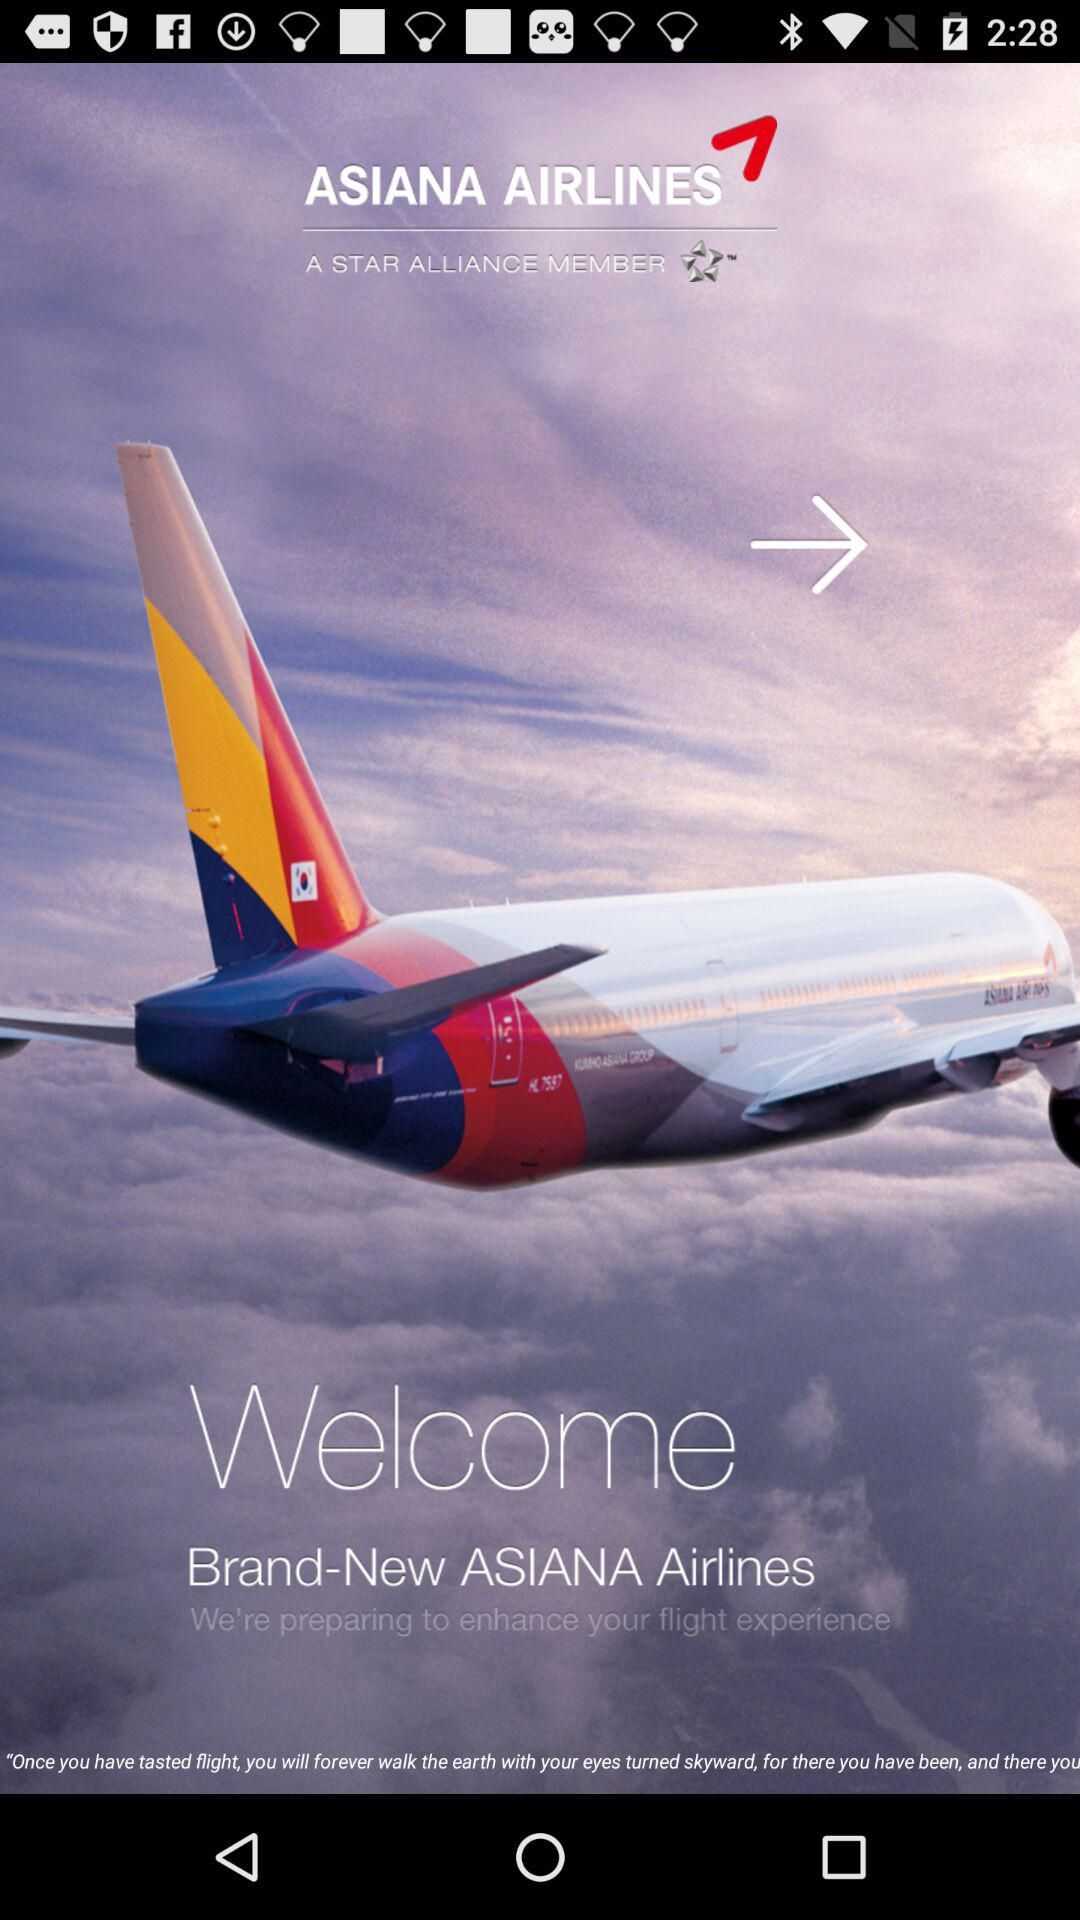What is the name of the application? The name of the application is "ASIANA AIRLINES". 